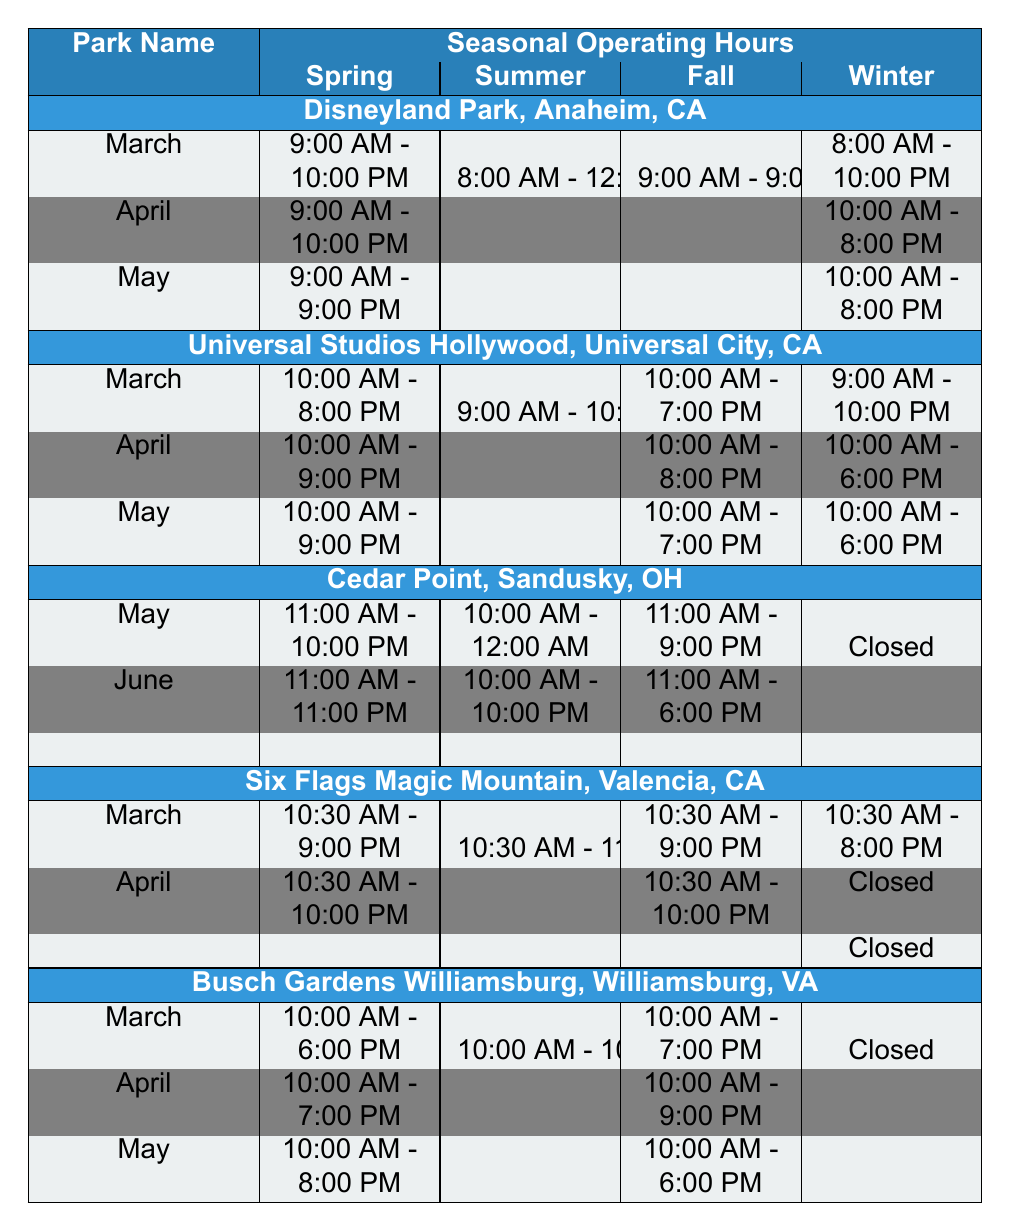What are the operating hours of Disneyland Park in May? Disneyland Park's operating hours for May are shown in the Spring section of the table. It indicates that in May, the park operates from 9:00 AM to 9:00 PM.
Answer: 9:00 AM - 9:00 PM Which park has the longest operating hours in July? To find the longest operating hours in July, I compare the hours for all listed parks. Disneyland Park and Universal Studios Hollywood both operate from 8:00 AM to 12:00 AM, while Cedar Point operates until 12:00 AM. Therefore, Cedar Point has the longest hours at 12 hours.
Answer: Cedar Point Is Cedar Point open during winter? The table specifies that Cedar Point is closed from January to March, indicating that it does not operate in winter.
Answer: No What are the March operating hours for Six Flags Magic Mountain? In the table, the operating hours for March at Six Flags Magic Mountain are listed as 10:30 AM to 9:00 PM.
Answer: 10:30 AM - 9:00 PM How much longer does Disneyland Park operate in summer compared to winter? In summer, Disneyland Park is open from 8:00 AM to 12:00 AM (16 hours), while in winter, it operates from 8:00 AM to 10:00 PM (14 hours). The difference in operating hours is 16 - 14 = 2 hours longer in summer.
Answer: 2 hours Which park has the same operating hours for June and July? By examining the hours for June and July, both Disneyland Park and Universal Studios Hollywood operate from 8:00 AM to 12:00 AM in those months. Thus, they share the same operating hours for June and July.
Answer: Disneyland Park and Universal Studios Hollywood Does Busch Gardens Williamsburg operate any day during winter? According to the table, Busch Gardens Williamsburg is closed for all three winter months (December to February), meaning it operates no days during winter.
Answer: No What are the total operating hours for Cedar Point in summer if it opens every day in July? Cedar Point operates from 10:00 AM to 12:00 AM (14 hours) in July. If it opens every day, the total operating hours for July would be calculated as 14 hours/day * 31 days = 434 hours.
Answer: 434 hours In which month does Universal Studios Hollywood open earlier? By analyzing the operating hours, Universal Studios Hollywood opens at 9:00 AM in June and July, but at 10:00 AM in March and April. Thus, it opens earlier in June.
Answer: June What is the average operating time per day for Six Flags Magic Mountain throughout spring? For Six Flags Magic Mountain, March operating hours are 10.5 (9:00 PM - 10:30 AM), April is 11.5, and there are no specified hours for May. The average for the two months is (10.5 + 11.5)/2 = 11 hours per day on average for spring.
Answer: 11 hours 